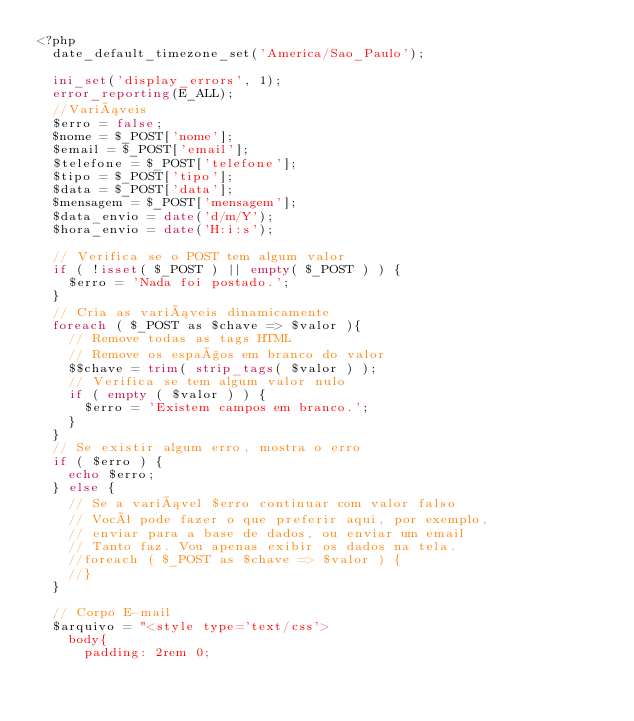Convert code to text. <code><loc_0><loc_0><loc_500><loc_500><_PHP_><?php
	date_default_timezone_set('America/Sao_Paulo');

	ini_set('display_errors', 1);
	error_reporting(E_ALL);
	//Variáveis 
	$erro = false;
	$nome = $_POST['nome'];
	$email = $_POST['email'];
	$telefone = $_POST['telefone'];
	$tipo = $_POST['tipo'];
	$data = $_POST['data'];
	$mensagem = $_POST['mensagem'];
	$data_envio = date('d/m/Y');
	$hora_envio = date('H:i:s');

	// Verifica se o POST tem algum valor
	if ( !isset( $_POST ) || empty( $_POST ) ) {
		$erro = 'Nada foi postado.';
	}
	// Cria as variáveis dinamicamente
	foreach ( $_POST as $chave => $valor ){
		// Remove todas as tags HTML
		// Remove os espaços em branco do valor
		$$chave = trim( strip_tags( $valor ) );
		// Verifica se tem algum valor nulo
		if ( empty ( $valor ) ) {
			$erro = 'Existem campos em branco.';
		}
	}
	// Se existir algum erro, mostra o erro
	if ( $erro ) {
		echo $erro;
	} else {
		// Se a variável $erro continuar com valor falso
		// Você pode fazer o que preferir aqui, por exemplo, 
		// enviar para a base de dados, ou enviar um email
		// Tanto faz. Vou apenas exibir os dados na tela.
		//foreach ( $_POST as $chave => $valor ) {
		//}
	}

	// Corpo E-mail
	$arquivo = "<style type='text/css'>
		body{
			padding: 2rem 0;</code> 